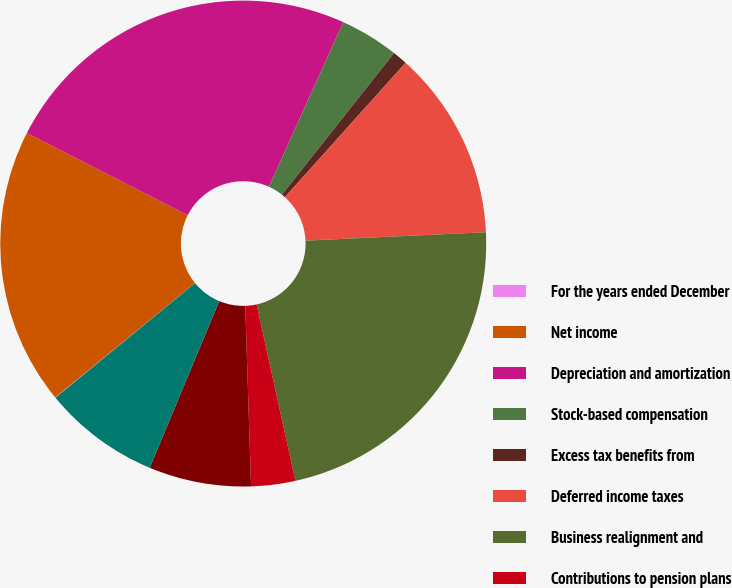Convert chart. <chart><loc_0><loc_0><loc_500><loc_500><pie_chart><fcel>For the years ended December<fcel>Net income<fcel>Depreciation and amortization<fcel>Stock-based compensation<fcel>Excess tax benefits from<fcel>Deferred income taxes<fcel>Business realignment and<fcel>Contributions to pension plans<fcel>Accounts receivable-trade<fcel>Inventories<nl><fcel>0.03%<fcel>18.43%<fcel>24.24%<fcel>3.9%<fcel>0.99%<fcel>12.61%<fcel>22.3%<fcel>2.93%<fcel>6.8%<fcel>7.77%<nl></chart> 